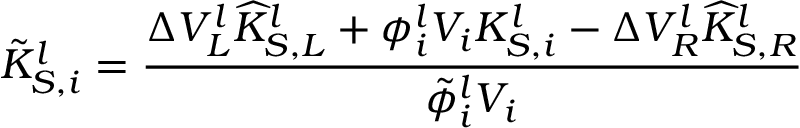<formula> <loc_0><loc_0><loc_500><loc_500>\tilde { K } _ { S , i } ^ { l } = \frac { \Delta V _ { L } ^ { l } \widehat { K } _ { S , L } ^ { l } + \phi _ { i } ^ { l } V _ { i } K _ { S , i } ^ { l } - \Delta V _ { R } ^ { l } \widehat { K } _ { S , R } ^ { l } } { \tilde { \phi } _ { i } ^ { l } V _ { i } }</formula> 